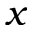Convert formula to latex. <formula><loc_0><loc_0><loc_500><loc_500>x</formula> 